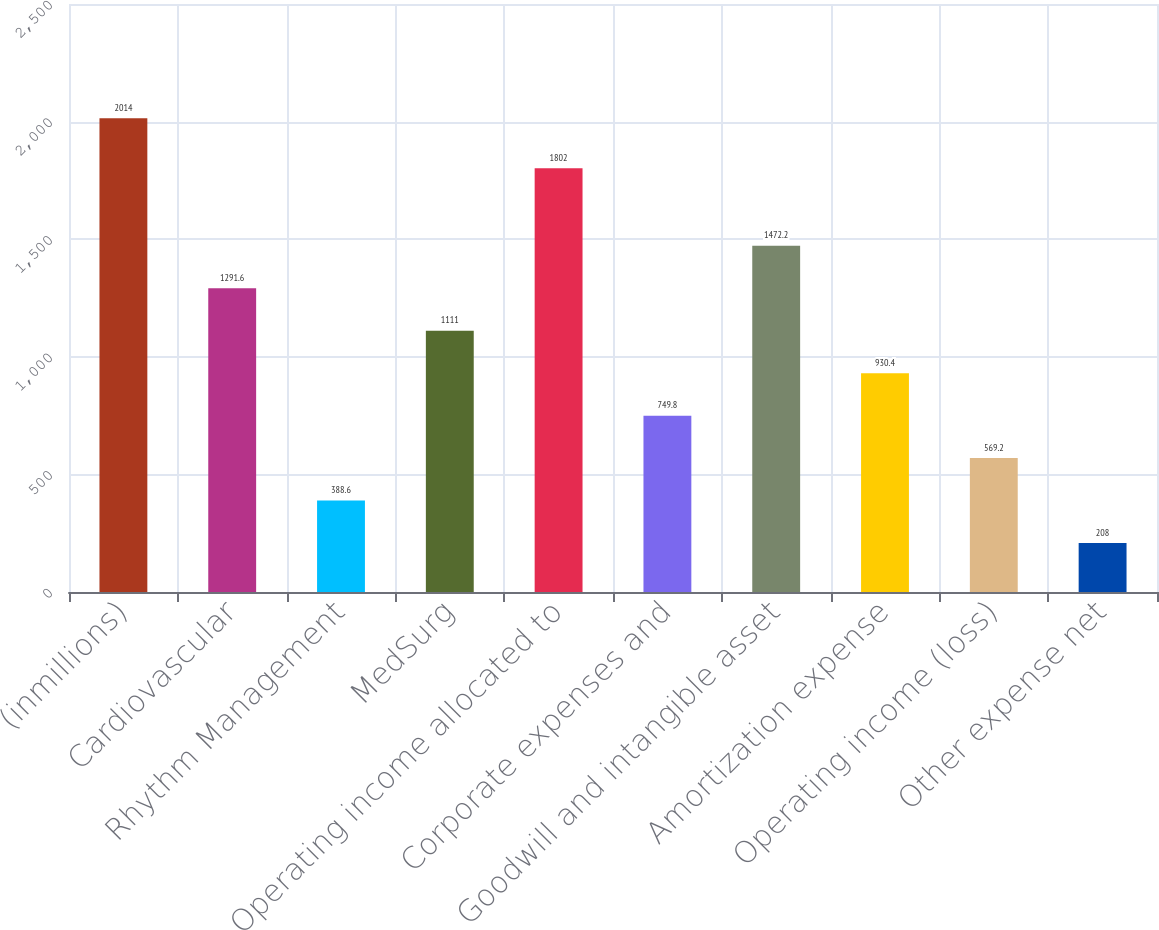Convert chart. <chart><loc_0><loc_0><loc_500><loc_500><bar_chart><fcel>(inmillions)<fcel>Cardiovascular<fcel>Rhythm Management<fcel>MedSurg<fcel>Operating income allocated to<fcel>Corporate expenses and<fcel>Goodwill and intangible asset<fcel>Amortization expense<fcel>Operating income (loss)<fcel>Other expense net<nl><fcel>2014<fcel>1291.6<fcel>388.6<fcel>1111<fcel>1802<fcel>749.8<fcel>1472.2<fcel>930.4<fcel>569.2<fcel>208<nl></chart> 